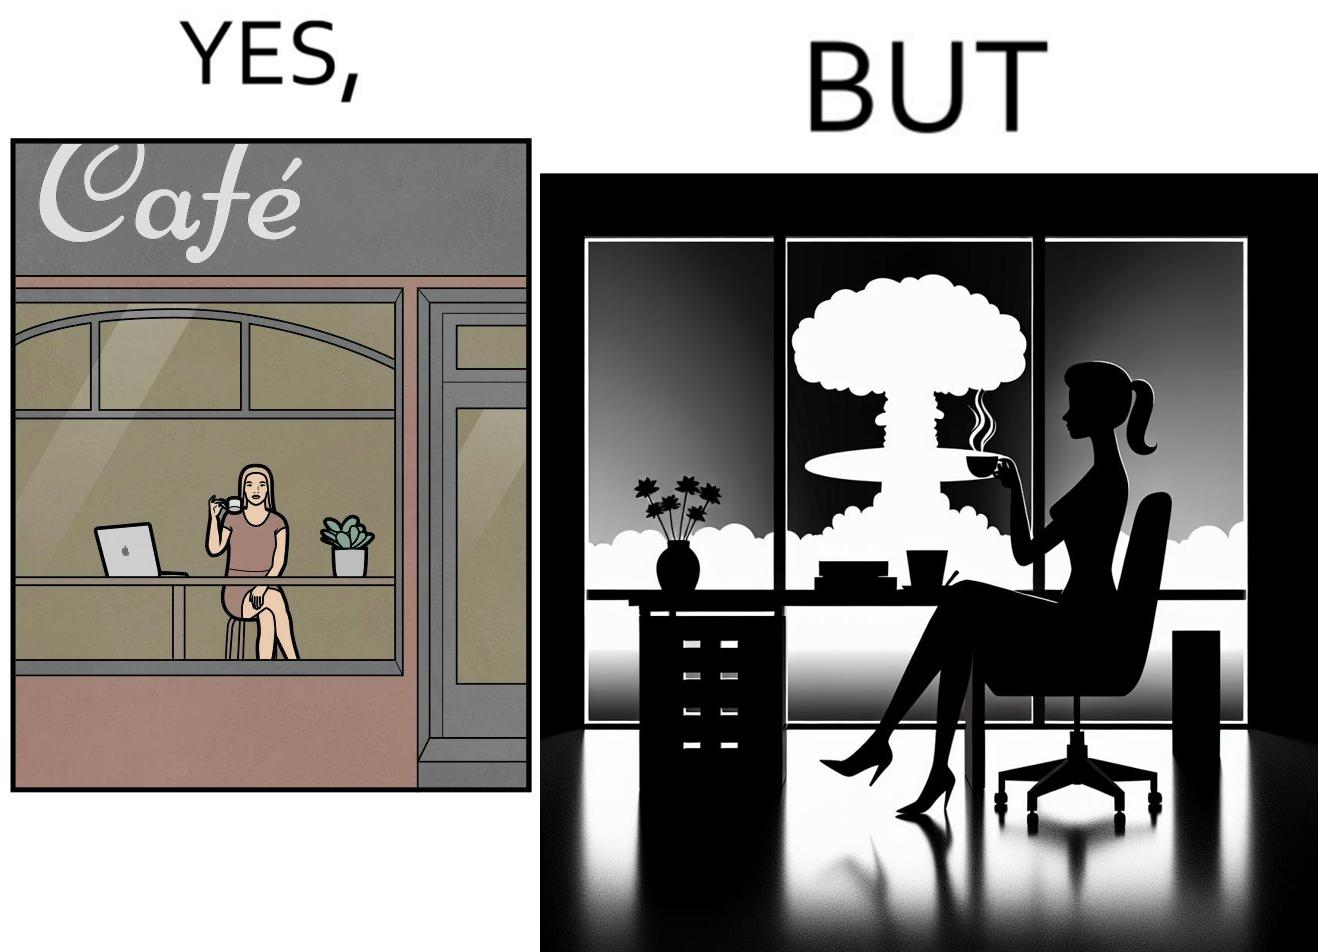Describe what you see in the left and right parts of this image. In the left part of the image: A woman sipping from a cup in a cafe with her laptop In the right part of the image: A woman sipping from a cup while looking at a nuclear blast from her desk 